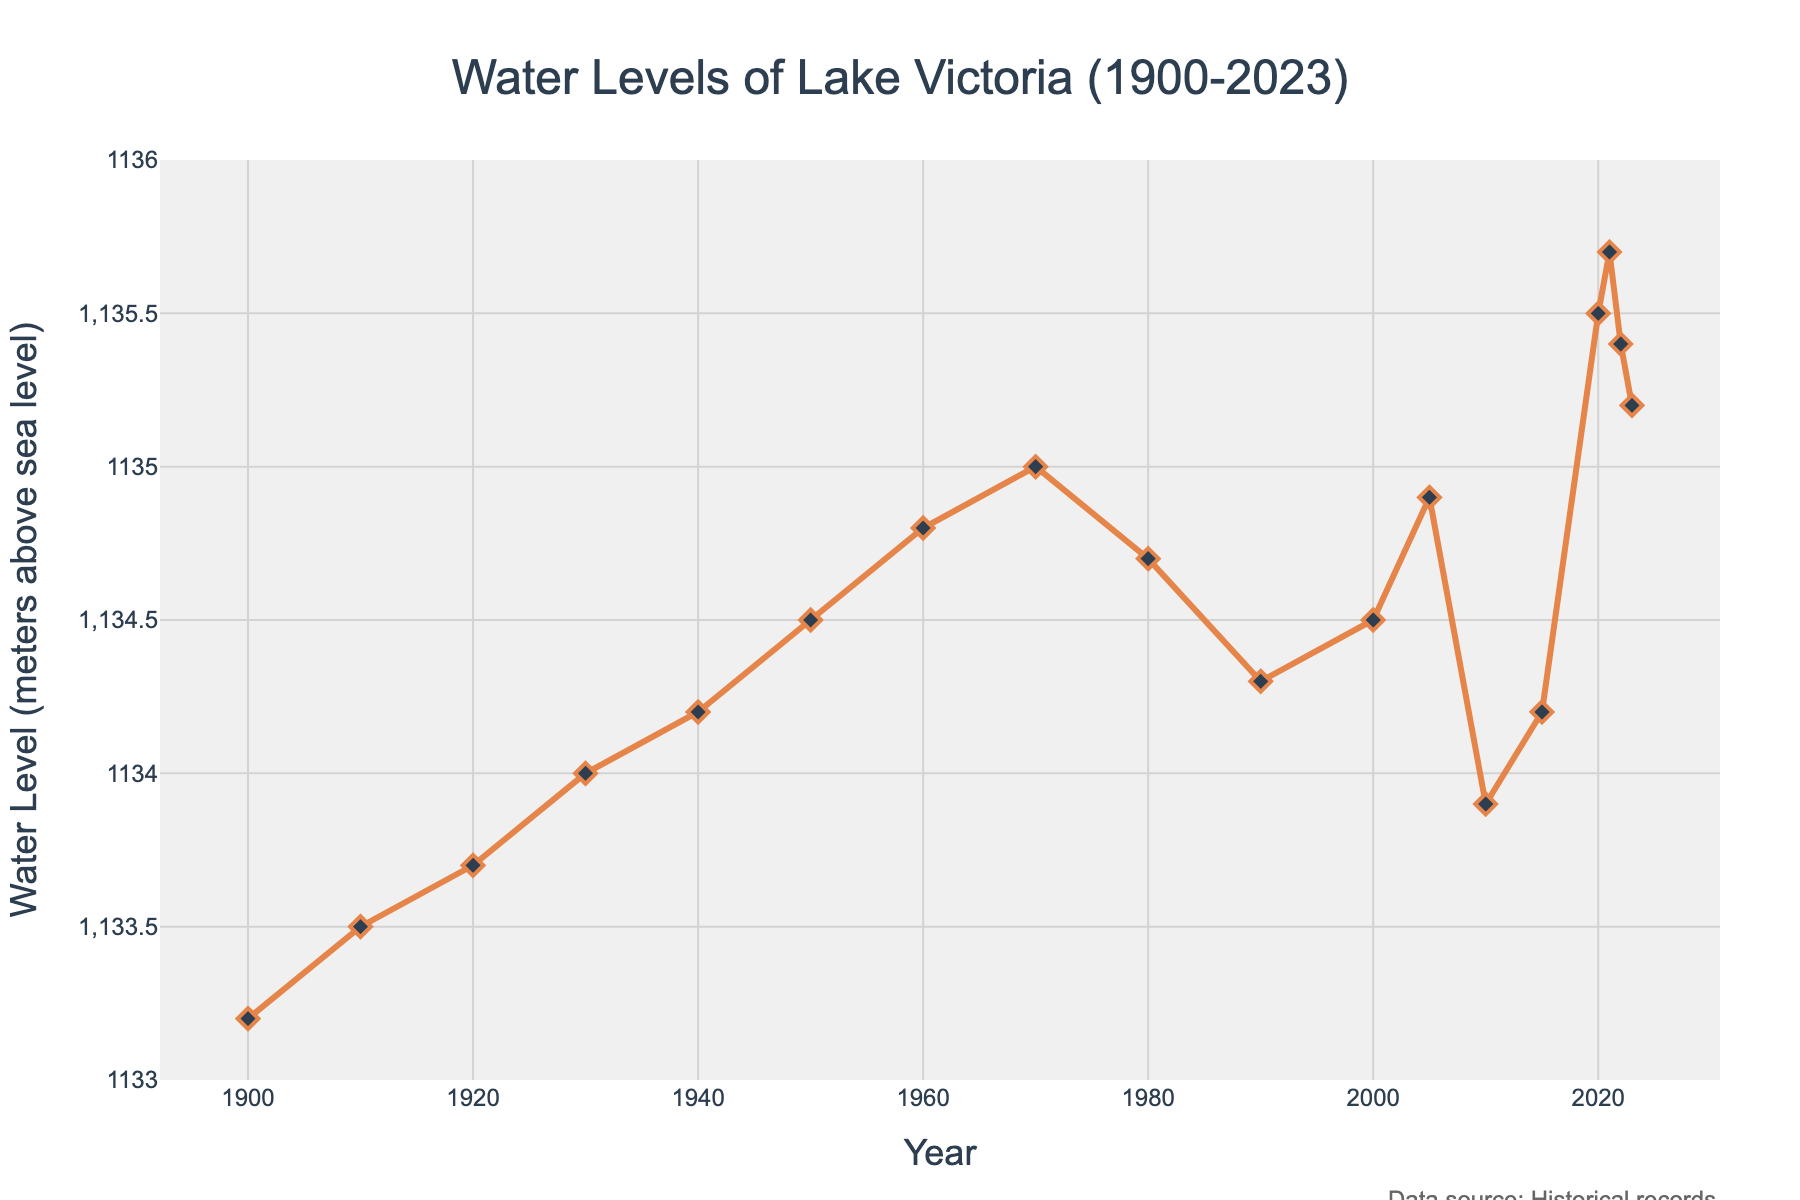What year saw the highest water level in Lake Victoria? The highest water level in the figure is recorded at 1135.7 meters above sea level. By examining the plot, this peak occurs in the year 2021.
Answer: 2021 In which decade did water levels of Lake Victoria first surpass 1134 meters? In the figure, the water level surpasses 1134 meters for the first time during the decade of the 1930s. Specifically, it rises above 1134 meters in 1930.
Answer: 1930s What is the difference in water levels between the years 1900 and 2020? From the figure, the water level in 1900 is 1133.2 meters and in 2020 it is 1135.5 meters. Subtracting the 1900 level from the 2020 level: 1135.5 - 1133.2 = 2.3 meters.
Answer: 2.3 meters Compare the water levels in 2005 and 2010. Which year had a higher water level, and by how much? The water level in 2005 is 1134.9 meters and in 2010 it is 1133.9 meters. 2005 has the higher water level. The difference is: 1134.9 - 1133.9 = 1 meter.
Answer: 2005, 1 meter What is the average water level of Lake Victoria during the decade of the 1950s? The water level data for the 1950s shows a single point at 1134.5 meters. Since there is only one value available for this decade, the average is simply 1134.5 meters.
Answer: 1134.5 meters What trend do you observe in the water levels from 1980 to 1990? Observing the plot from 1980 to 1990, the water level decreases over this period, going from 1134.7 meters in 1980 to 1134.3 meters in 1990.
Answer: Declining trend What is the range of water levels observed between 2000 and 2023? The range is calculated by subtracting the minimum water level from the maximum water level between 2000 and 2023. The minimum is 1133.9 meters (2010) and the maximum is 1135.7 meters (2021). The range is 1135.7 - 1133.9 = 1.8 meters.
Answer: 1.8 meters In how many years did the water level exceed 1135 meters? By observing the figure, the water level exceeds 1135 meters in the years 2020, 2021, 2022, and 2023. So, this happens in 4 years.
Answer: 4 years What visual markers are used to represent each data point on the plot? Referring to the description, each data point is represented using diamonds, with a combination of lines and markers.
Answer: Diamonds 